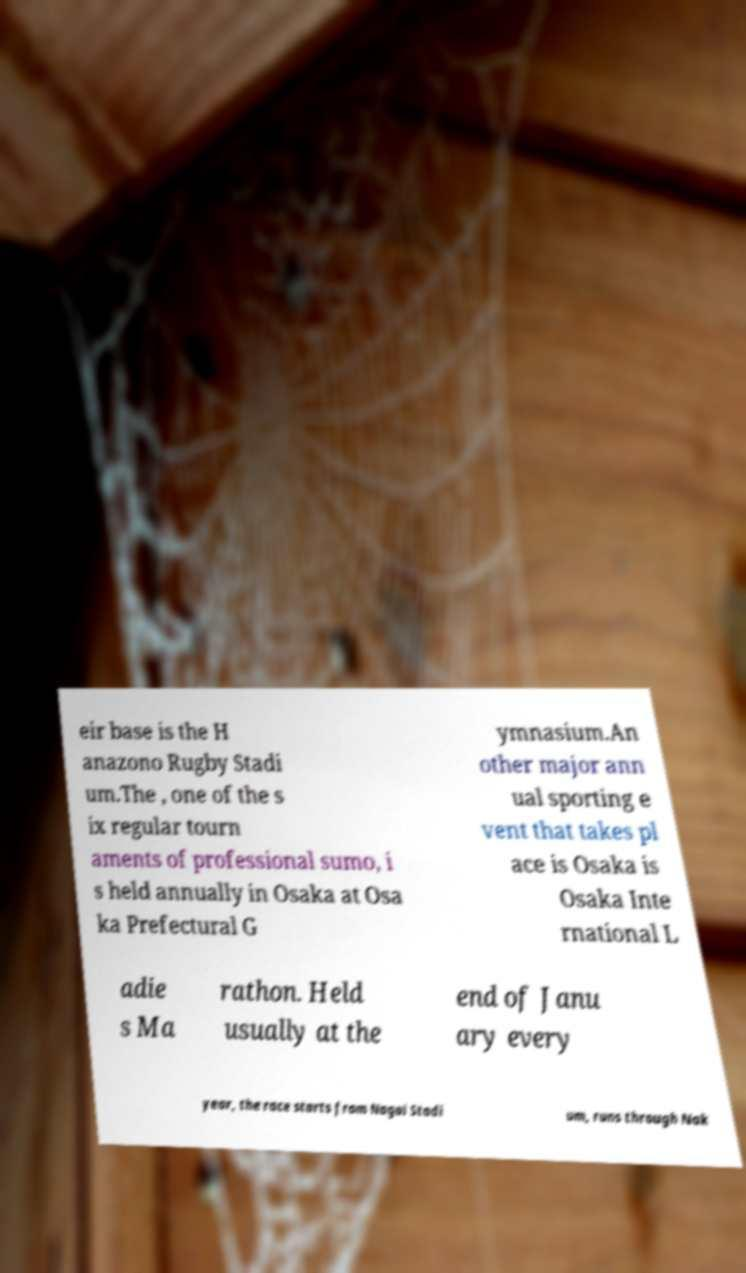Can you read and provide the text displayed in the image?This photo seems to have some interesting text. Can you extract and type it out for me? eir base is the H anazono Rugby Stadi um.The , one of the s ix regular tourn aments of professional sumo, i s held annually in Osaka at Osa ka Prefectural G ymnasium.An other major ann ual sporting e vent that takes pl ace is Osaka is Osaka Inte rnational L adie s Ma rathon. Held usually at the end of Janu ary every year, the race starts from Nagai Stadi um, runs through Nak 